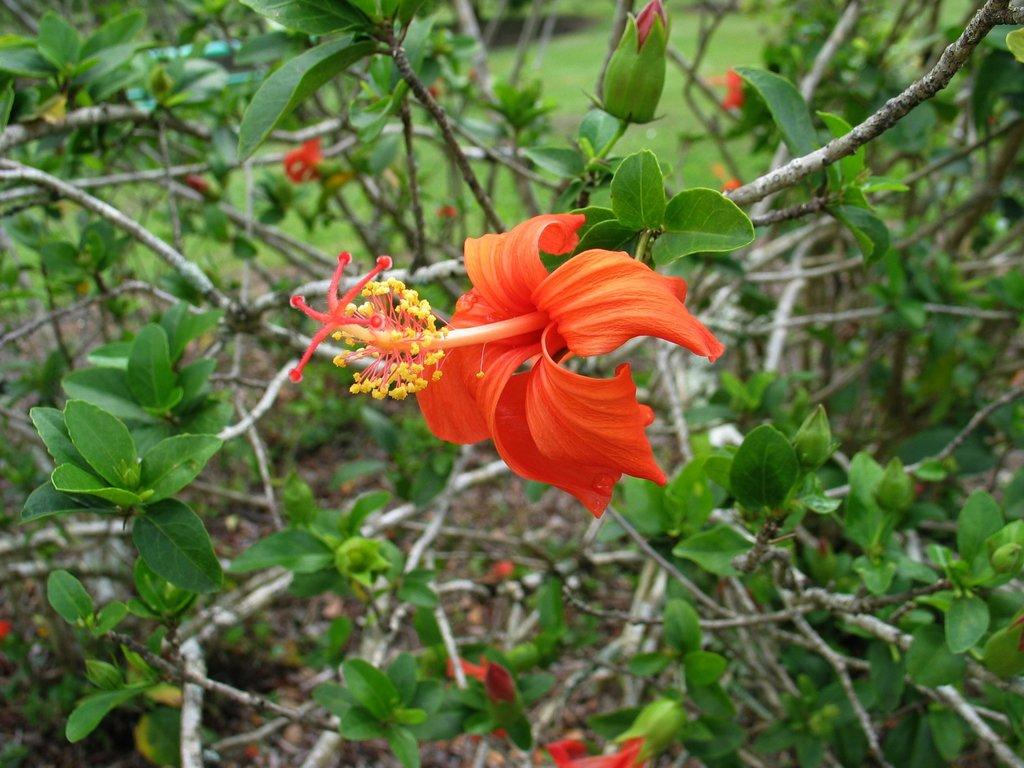What type of flower is present in the image? There is an orange color Hibiscus flower in the image. What is the growth stage of the plants in the image? There are buds on the plants in the image. How would you describe the background of the image? The background of the image is blurred. What type of vegetation can be seen in the blurred background? Grass is visible in the blurred background. How does the ladybug make its decision to land on the Hibiscus flower in the image? There is no ladybug present in the image, so it is not possible to determine how it would make a decision. 